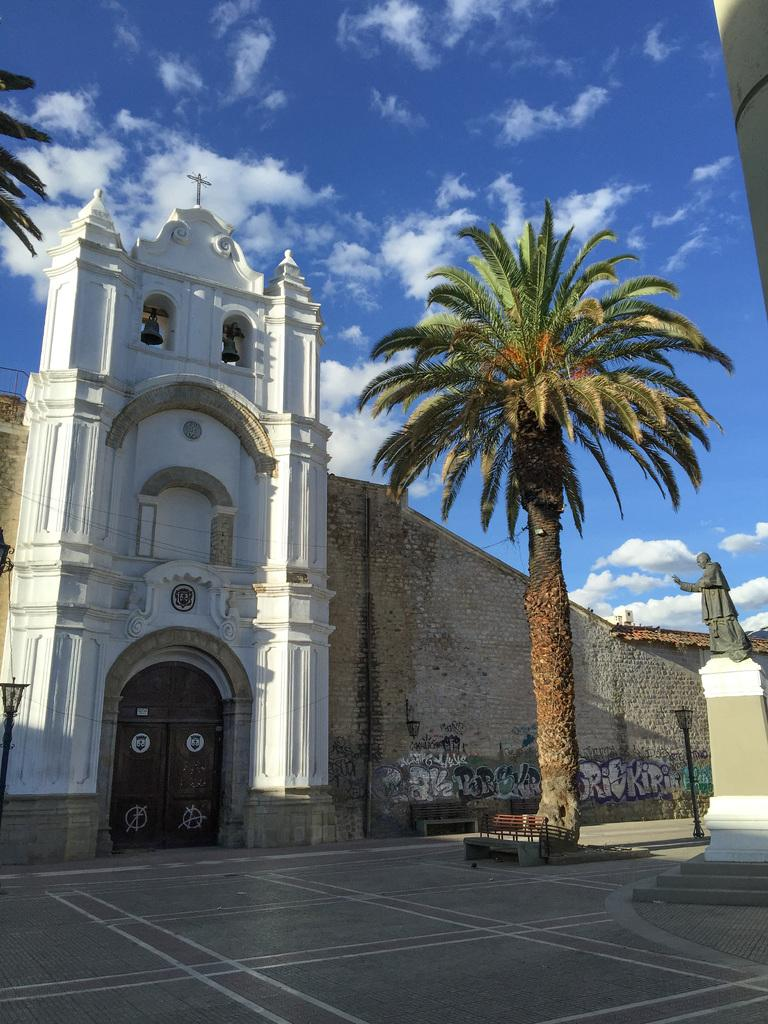What type of vegetation is present in the image? There are trees in the image. What structure can be seen in the image? There is a pole in the image. What type of artwork is featured in the image? There is a statue in the image. What can be seen in the background of the image? There is a building, clouds, and the sky visible in the background of the image. What type of soda is being served in the image? There is no soda present in the image. What type of food is being prepared in the image? There is no food preparation visible in the image. 